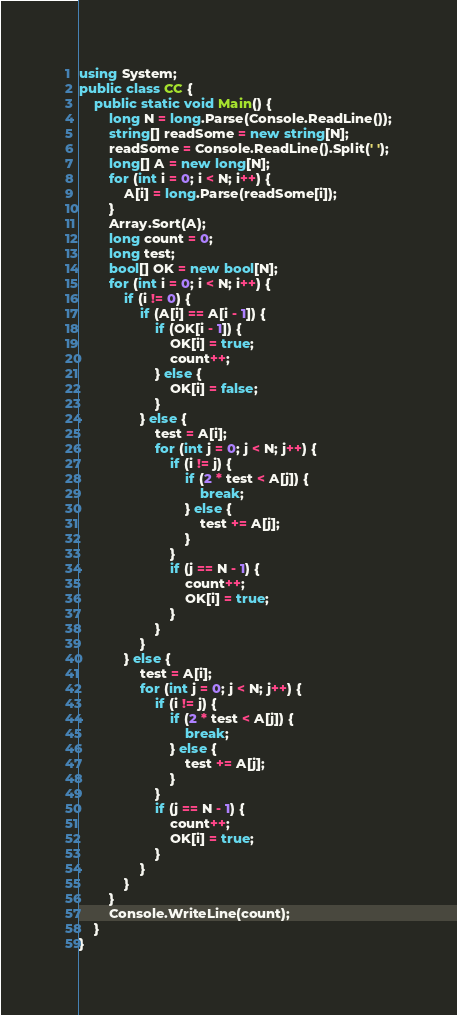Convert code to text. <code><loc_0><loc_0><loc_500><loc_500><_C#_>using System;
public class CC {
    public static void Main() {
        long N = long.Parse(Console.ReadLine());
        string[] readSome = new string[N];
        readSome = Console.ReadLine().Split(' ');
        long[] A = new long[N];
        for (int i = 0; i < N; i++) {
            A[i] = long.Parse(readSome[i]);
        }
        Array.Sort(A);
        long count = 0;
        long test;
        bool[] OK = new bool[N];
        for (int i = 0; i < N; i++) {
            if (i != 0) {
                if (A[i] == A[i - 1]) {
                    if (OK[i - 1]) {
                        OK[i] = true;
                        count++;
                    } else {
                        OK[i] = false;
                    }
                } else {
                    test = A[i];
                    for (int j = 0; j < N; j++) {
                        if (i != j) {
                            if (2 * test < A[j]) {
                                break;
                            } else {
                                test += A[j];
                            }
                        }
                        if (j == N - 1) {
                            count++;
                            OK[i] = true;
                        }
                    }
                }
            } else {
                test = A[i];
                for (int j = 0; j < N; j++) {
                    if (i != j) {
                        if (2 * test < A[j]) {
                            break;
                        } else {
                            test += A[j];
                        }
                    }
                    if (j == N - 1) {
                        count++;
                        OK[i] = true;
                    }
                }
            }
        }
        Console.WriteLine(count);
    }
}</code> 